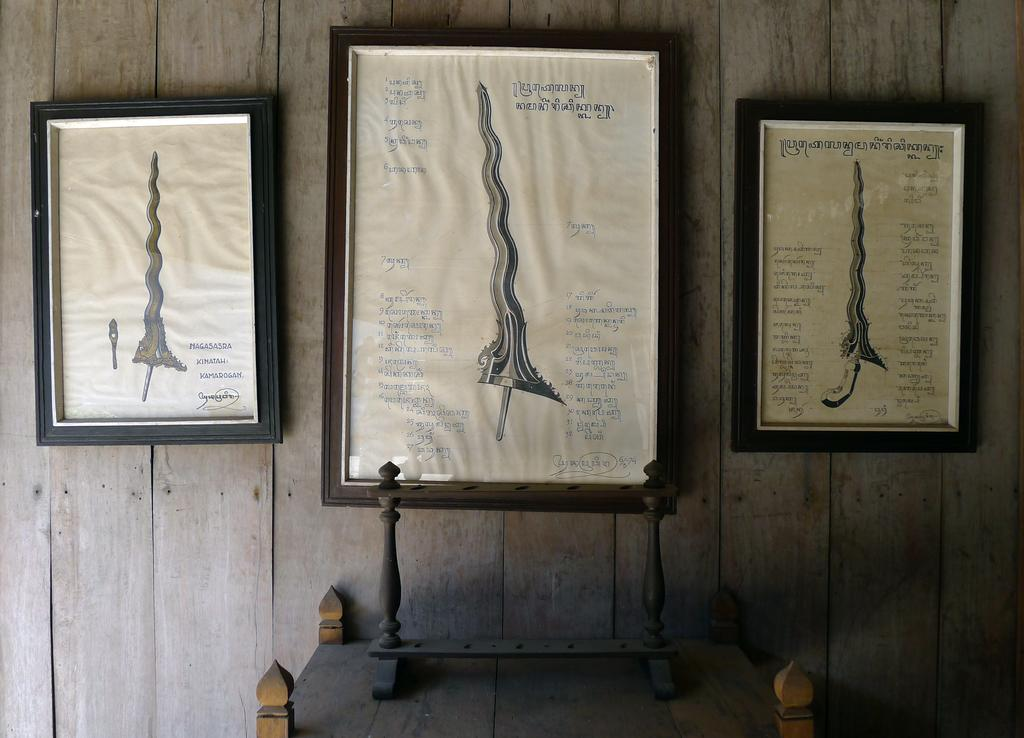How many photo frames are visible in the image? There are three photo frames in the image. Where are the photo frames located? The photo frames are attached to a wooden wall. What is present at the bottom of the image? There is an object on a table at the bottom of the image. What can is being used to cause a smile in the image? There is no can or any object being used to cause a smile in the image. 